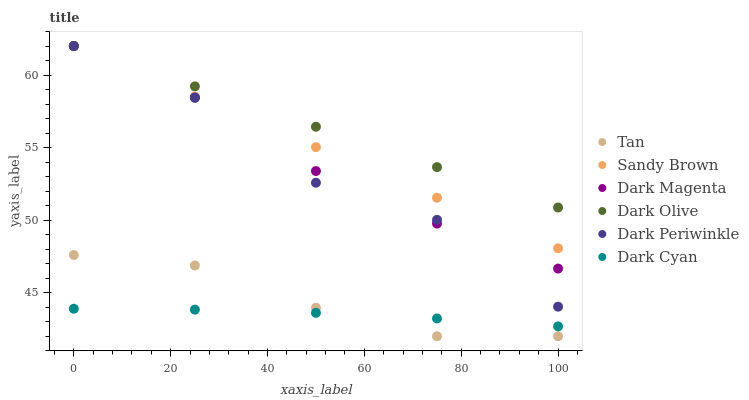Does Dark Cyan have the minimum area under the curve?
Answer yes or no. Yes. Does Dark Olive have the maximum area under the curve?
Answer yes or no. Yes. Does Dark Olive have the minimum area under the curve?
Answer yes or no. No. Does Dark Cyan have the maximum area under the curve?
Answer yes or no. No. Is Sandy Brown the smoothest?
Answer yes or no. Yes. Is Dark Periwinkle the roughest?
Answer yes or no. Yes. Is Dark Olive the smoothest?
Answer yes or no. No. Is Dark Olive the roughest?
Answer yes or no. No. Does Tan have the lowest value?
Answer yes or no. Yes. Does Dark Cyan have the lowest value?
Answer yes or no. No. Does Dark Periwinkle have the highest value?
Answer yes or no. Yes. Does Dark Cyan have the highest value?
Answer yes or no. No. Is Dark Cyan less than Sandy Brown?
Answer yes or no. Yes. Is Dark Magenta greater than Dark Cyan?
Answer yes or no. Yes. Does Dark Magenta intersect Dark Periwinkle?
Answer yes or no. Yes. Is Dark Magenta less than Dark Periwinkle?
Answer yes or no. No. Is Dark Magenta greater than Dark Periwinkle?
Answer yes or no. No. Does Dark Cyan intersect Sandy Brown?
Answer yes or no. No. 